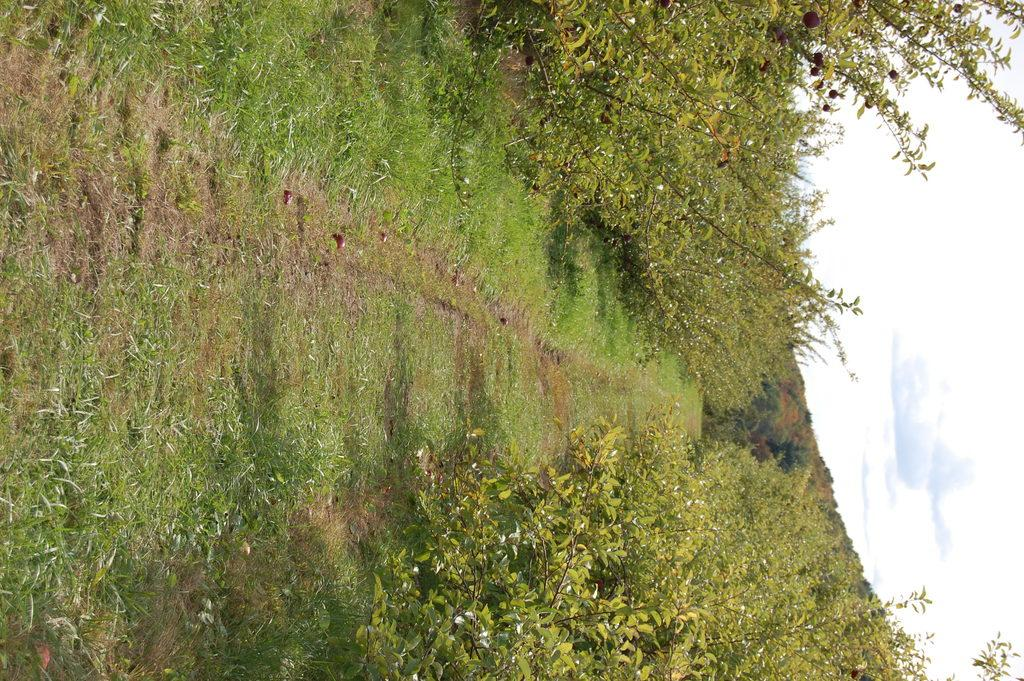What type of vegetation can be seen in the image? There is grass, plants, and trees in the image. What is visible on the right side of the image? The sky is visible on the right side of the image. What can be seen in the sky? Clouds are present in the sky. Where is the monkey located in the image? There is no monkey present in the image. What type of battle is taking place in the image? There is no battle present in the image. 